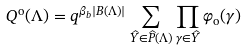<formula> <loc_0><loc_0><loc_500><loc_500>Q ^ { \text {o} } ( \Lambda ) = q ^ { \beta _ { b } | B ( \Lambda ) | } \sum _ { \widehat { Y } \in \widehat { P } ( \Lambda ) } \prod _ { \gamma \in \widehat { Y } } \varphi _ { \text {o} } ( \gamma )</formula> 